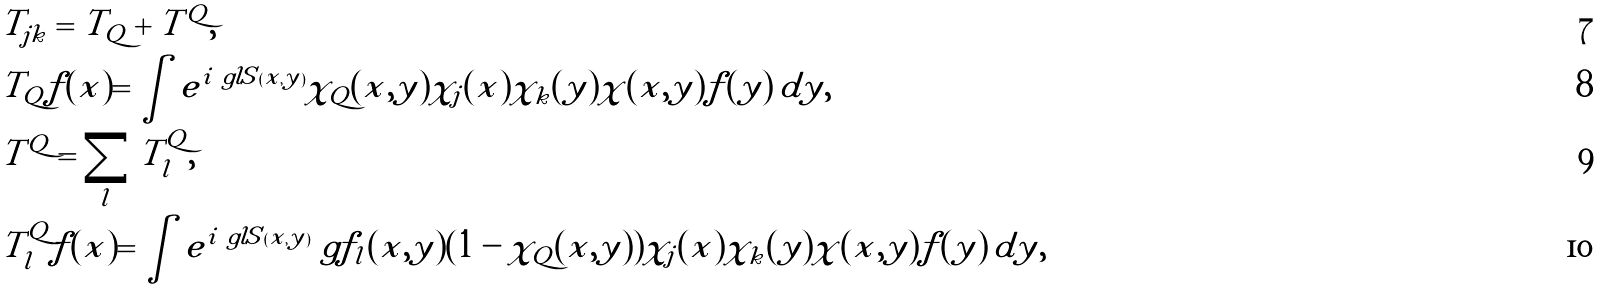Convert formula to latex. <formula><loc_0><loc_0><loc_500><loc_500>& T _ { j k } = T _ { Q } + T ^ { Q } , \\ & T _ { Q } f ( x ) = \int e ^ { i \ g l S ( x , y ) } \chi _ { Q } ( x , y ) \chi _ { j } ( x ) \chi _ { k } ( y ) \chi ( x , y ) f ( y ) \, d y , \\ & T ^ { Q } = \sum _ { l } T ^ { Q } _ { l } , \\ & T ^ { Q } _ { l } f ( x ) = \int e ^ { i \ g l S ( x , y ) } \ g f _ { l } ( x , y ) ( 1 - \chi _ { Q } ( x , y ) ) \chi _ { j } ( x ) \chi _ { k } ( y ) \chi ( x , y ) f ( y ) \, d y ,</formula> 